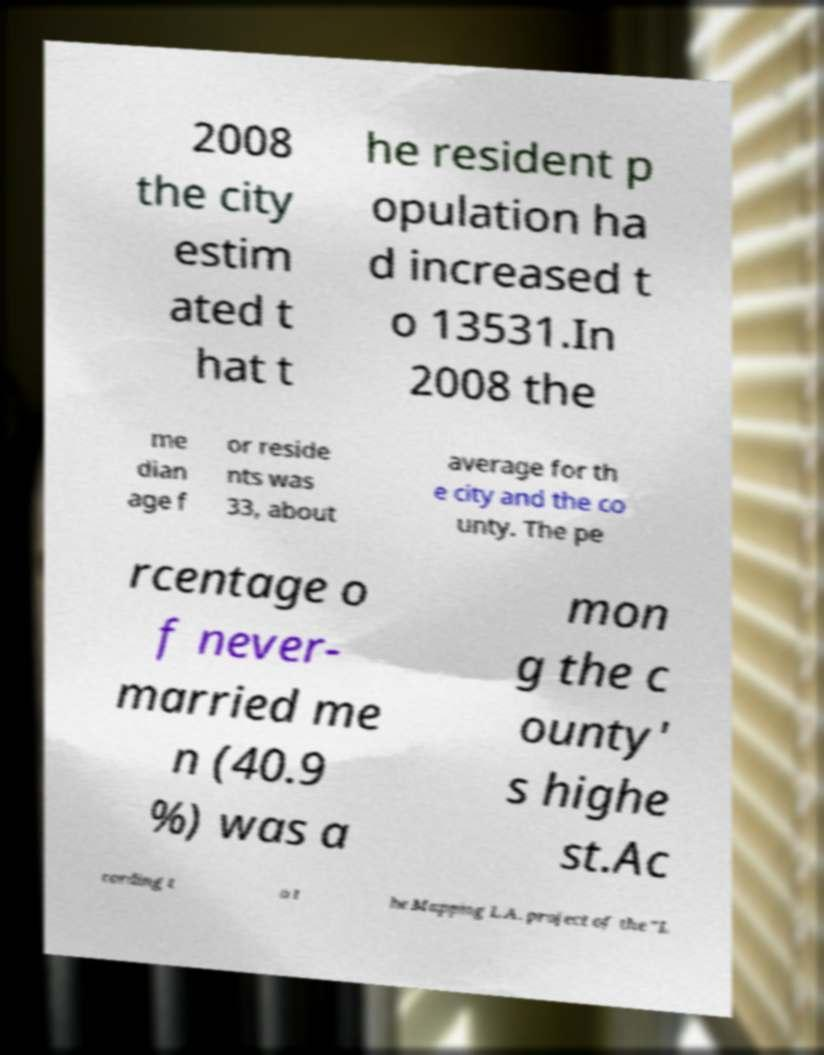Could you assist in decoding the text presented in this image and type it out clearly? 2008 the city estim ated t hat t he resident p opulation ha d increased t o 13531.In 2008 the me dian age f or reside nts was 33, about average for th e city and the co unty. The pe rcentage o f never- married me n (40.9 %) was a mon g the c ounty' s highe st.Ac cording t o t he Mapping L.A. project of the "L 